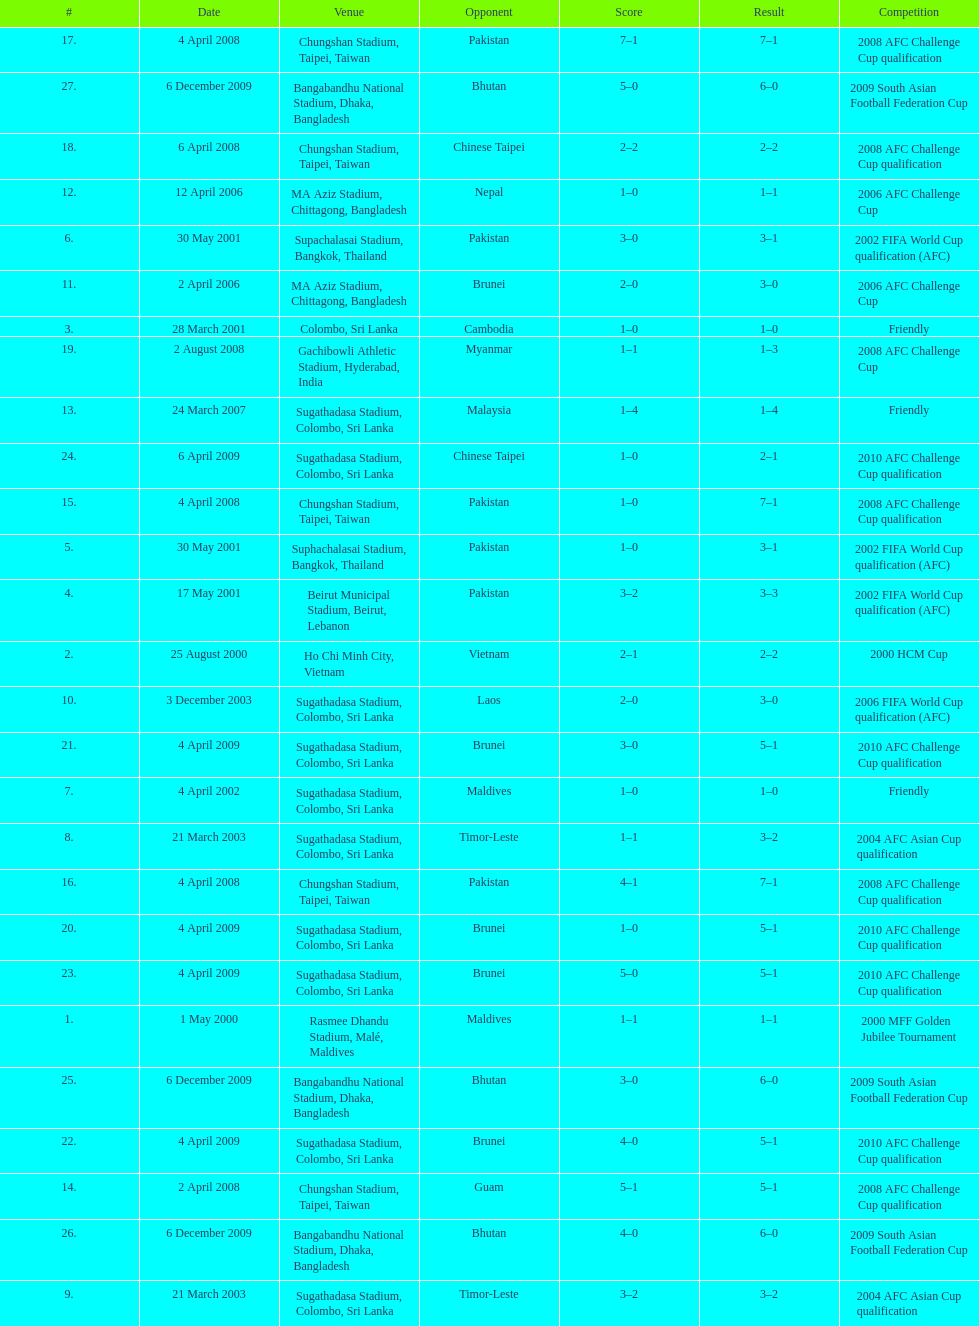What was the total number of goals score in the sri lanka - malaysia game of march 24, 2007? 5. 